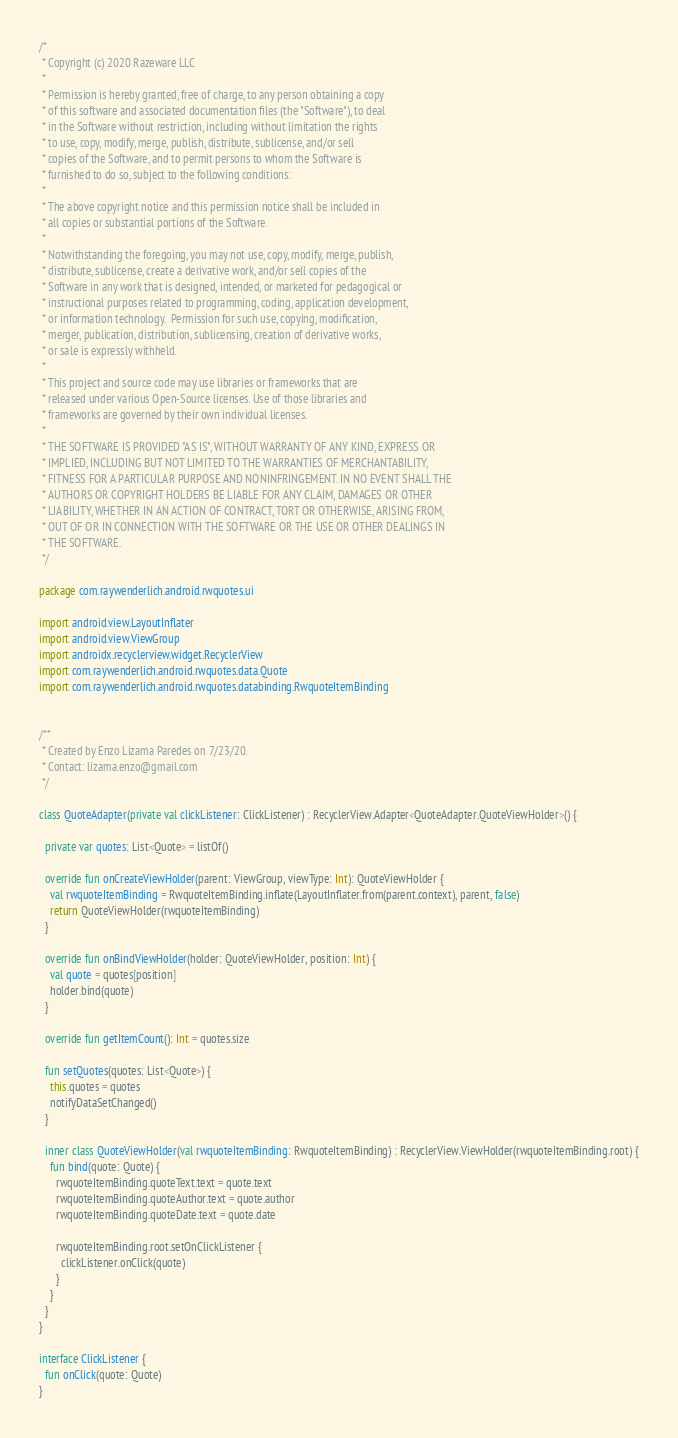Convert code to text. <code><loc_0><loc_0><loc_500><loc_500><_Kotlin_>/*
 * Copyright (c) 2020 Razeware LLC
 *
 * Permission is hereby granted, free of charge, to any person obtaining a copy
 * of this software and associated documentation files (the "Software"), to deal
 * in the Software without restriction, including without limitation the rights
 * to use, copy, modify, merge, publish, distribute, sublicense, and/or sell
 * copies of the Software, and to permit persons to whom the Software is
 * furnished to do so, subject to the following conditions:
 *
 * The above copyright notice and this permission notice shall be included in
 * all copies or substantial portions of the Software.
 *
 * Notwithstanding the foregoing, you may not use, copy, modify, merge, publish,
 * distribute, sublicense, create a derivative work, and/or sell copies of the
 * Software in any work that is designed, intended, or marketed for pedagogical or
 * instructional purposes related to programming, coding, application development,
 * or information technology.  Permission for such use, copying, modification,
 * merger, publication, distribution, sublicensing, creation of derivative works,
 * or sale is expressly withheld.
 *
 * This project and source code may use libraries or frameworks that are
 * released under various Open-Source licenses. Use of those libraries and
 * frameworks are governed by their own individual licenses.
 *
 * THE SOFTWARE IS PROVIDED "AS IS", WITHOUT WARRANTY OF ANY KIND, EXPRESS OR
 * IMPLIED, INCLUDING BUT NOT LIMITED TO THE WARRANTIES OF MERCHANTABILITY,
 * FITNESS FOR A PARTICULAR PURPOSE AND NONINFRINGEMENT. IN NO EVENT SHALL THE
 * AUTHORS OR COPYRIGHT HOLDERS BE LIABLE FOR ANY CLAIM, DAMAGES OR OTHER
 * LIABILITY, WHETHER IN AN ACTION OF CONTRACT, TORT OR OTHERWISE, ARISING FROM,
 * OUT OF OR IN CONNECTION WITH THE SOFTWARE OR THE USE OR OTHER DEALINGS IN
 * THE SOFTWARE.
 */

package com.raywenderlich.android.rwquotes.ui

import android.view.LayoutInflater
import android.view.ViewGroup
import androidx.recyclerview.widget.RecyclerView
import com.raywenderlich.android.rwquotes.data.Quote
import com.raywenderlich.android.rwquotes.databinding.RwquoteItemBinding


/**
 * Created by Enzo Lizama Paredes on 7/23/20.
 * Contact: lizama.enzo@gmail.com
 */

class QuoteAdapter(private val clickListener: ClickListener) : RecyclerView.Adapter<QuoteAdapter.QuoteViewHolder>() {

  private var quotes: List<Quote> = listOf()

  override fun onCreateViewHolder(parent: ViewGroup, viewType: Int): QuoteViewHolder {
    val rwquoteItemBinding = RwquoteItemBinding.inflate(LayoutInflater.from(parent.context), parent, false)
    return QuoteViewHolder(rwquoteItemBinding)
  }

  override fun onBindViewHolder(holder: QuoteViewHolder, position: Int) {
    val quote = quotes[position]
    holder.bind(quote)
  }

  override fun getItemCount(): Int = quotes.size

  fun setQuotes(quotes: List<Quote>) {
    this.quotes = quotes
    notifyDataSetChanged()
  }

  inner class QuoteViewHolder(val rwquoteItemBinding: RwquoteItemBinding) : RecyclerView.ViewHolder(rwquoteItemBinding.root) {
    fun bind(quote: Quote) {
      rwquoteItemBinding.quoteText.text = quote.text
      rwquoteItemBinding.quoteAuthor.text = quote.author
      rwquoteItemBinding.quoteDate.text = quote.date

      rwquoteItemBinding.root.setOnClickListener {
        clickListener.onClick(quote)
      }
    }
  }
}

interface ClickListener {
  fun onClick(quote: Quote)
}</code> 